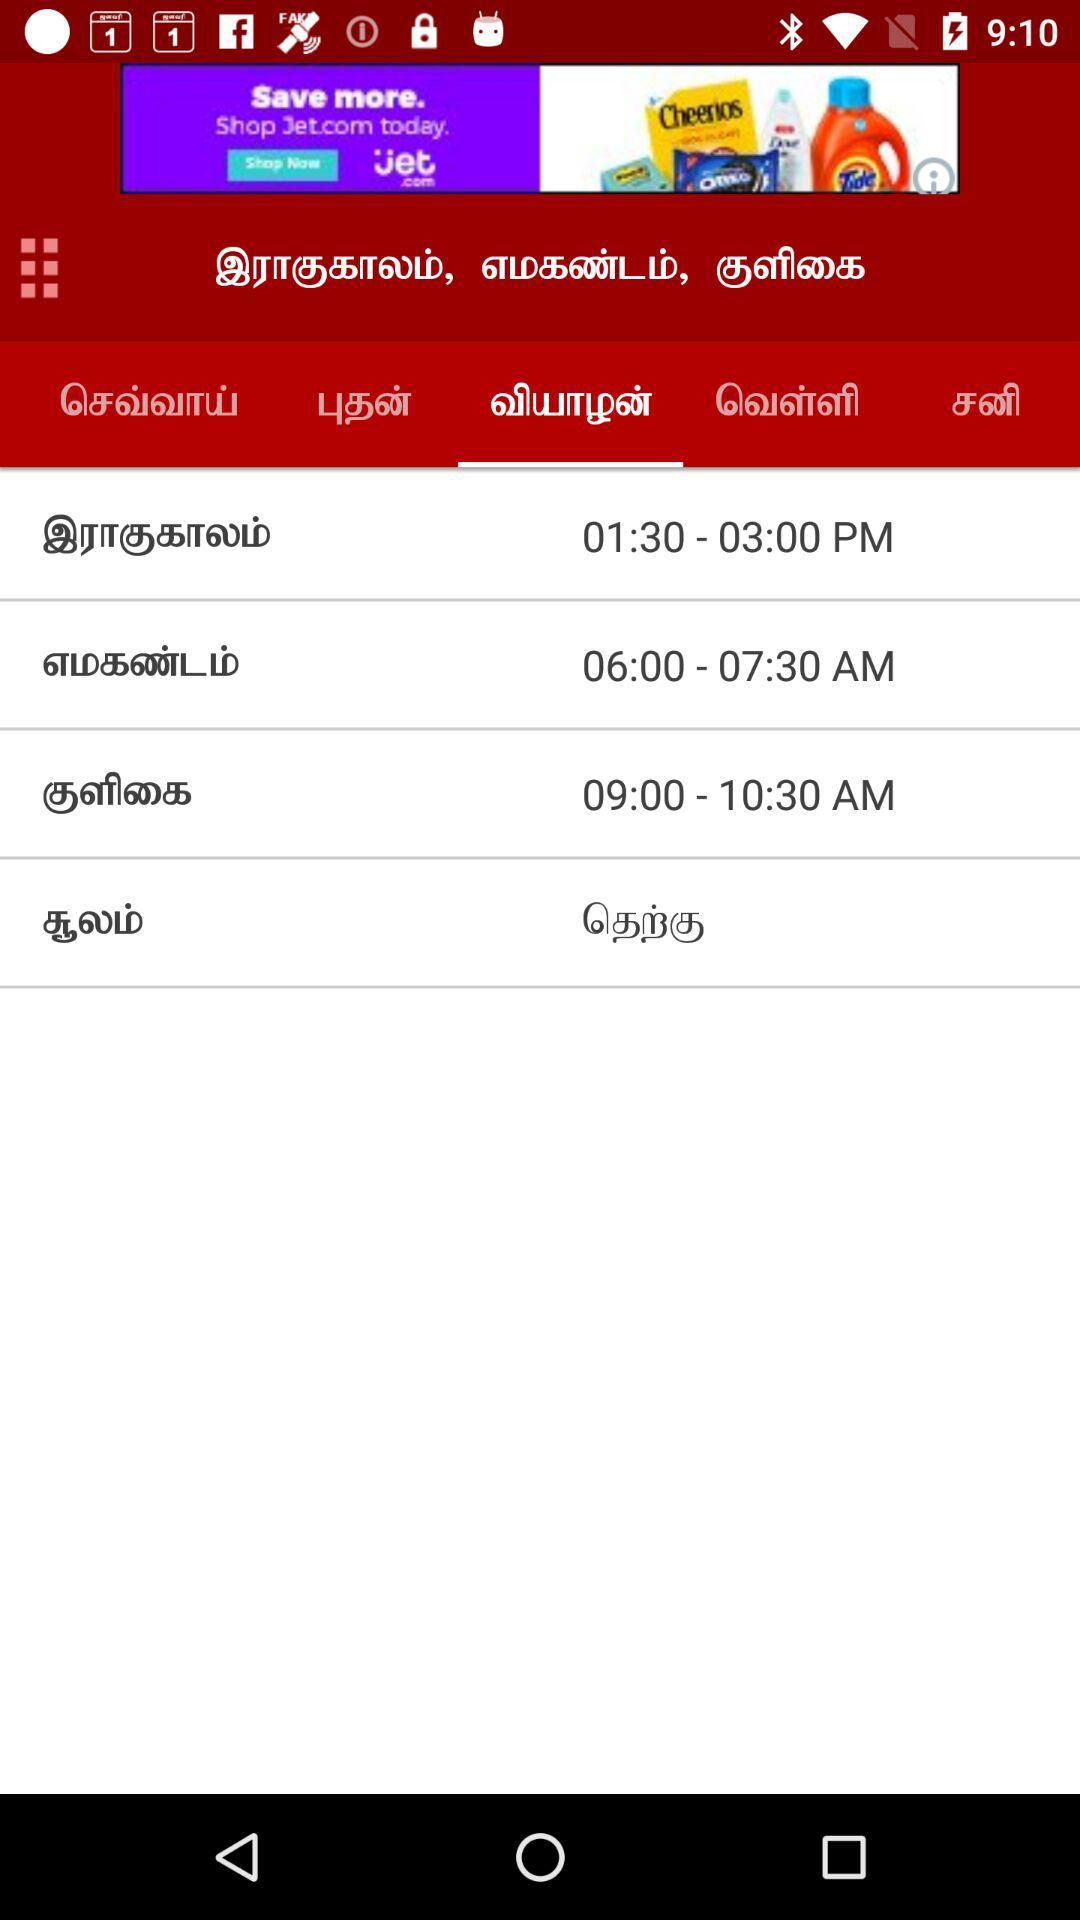How many auspicious times are there?
Answer the question using a single word or phrase. 3 